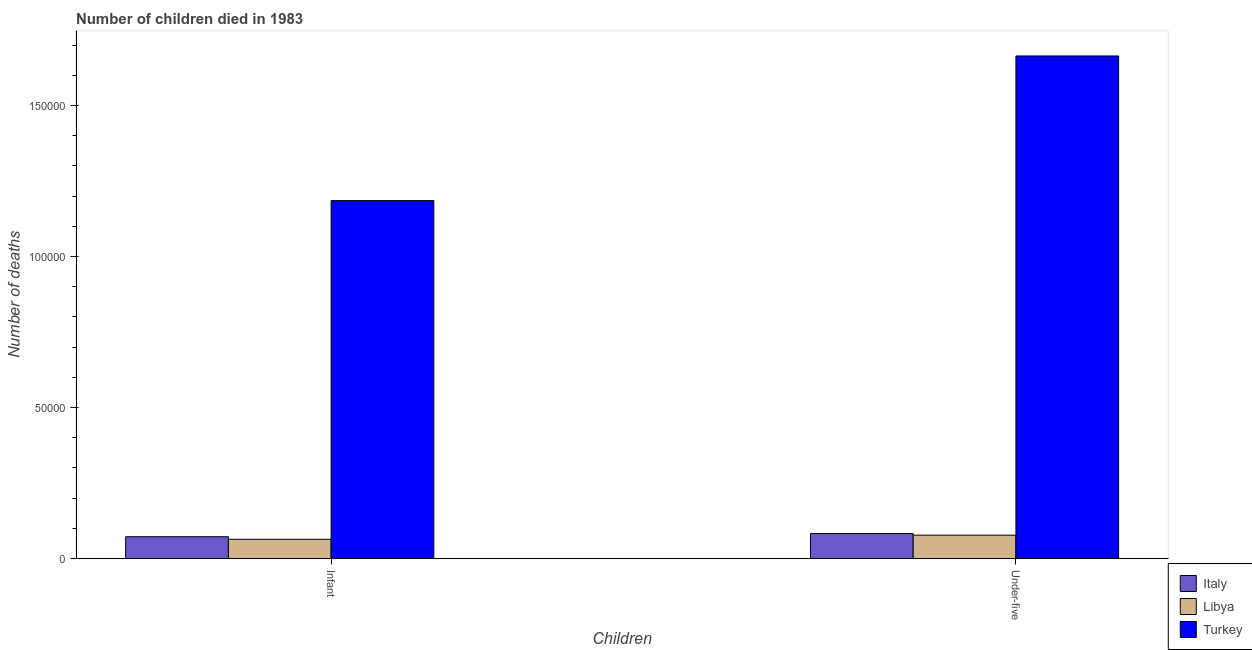Are the number of bars per tick equal to the number of legend labels?
Provide a succinct answer. Yes. Are the number of bars on each tick of the X-axis equal?
Offer a very short reply. Yes. How many bars are there on the 1st tick from the left?
Give a very brief answer. 3. What is the label of the 1st group of bars from the left?
Your answer should be compact. Infant. What is the number of infant deaths in Libya?
Your answer should be very brief. 6390. Across all countries, what is the maximum number of infant deaths?
Your answer should be very brief. 1.19e+05. Across all countries, what is the minimum number of under-five deaths?
Offer a very short reply. 7751. In which country was the number of under-five deaths minimum?
Provide a succinct answer. Libya. What is the total number of infant deaths in the graph?
Your answer should be very brief. 1.32e+05. What is the difference between the number of under-five deaths in Italy and that in Turkey?
Provide a succinct answer. -1.58e+05. What is the difference between the number of infant deaths in Libya and the number of under-five deaths in Italy?
Make the answer very short. -1890. What is the average number of under-five deaths per country?
Offer a terse response. 6.08e+04. What is the difference between the number of infant deaths and number of under-five deaths in Turkey?
Ensure brevity in your answer.  -4.79e+04. In how many countries, is the number of infant deaths greater than 110000 ?
Your answer should be very brief. 1. What is the ratio of the number of under-five deaths in Libya to that in Turkey?
Make the answer very short. 0.05. Is the number of infant deaths in Libya less than that in Turkey?
Offer a terse response. Yes. Are all the bars in the graph horizontal?
Give a very brief answer. No. Does the graph contain grids?
Offer a terse response. No. What is the title of the graph?
Your response must be concise. Number of children died in 1983. What is the label or title of the X-axis?
Offer a terse response. Children. What is the label or title of the Y-axis?
Ensure brevity in your answer.  Number of deaths. What is the Number of deaths of Italy in Infant?
Give a very brief answer. 7233. What is the Number of deaths of Libya in Infant?
Your answer should be compact. 6390. What is the Number of deaths in Turkey in Infant?
Make the answer very short. 1.19e+05. What is the Number of deaths of Italy in Under-five?
Your response must be concise. 8280. What is the Number of deaths in Libya in Under-five?
Provide a short and direct response. 7751. What is the Number of deaths in Turkey in Under-five?
Keep it short and to the point. 1.66e+05. Across all Children, what is the maximum Number of deaths of Italy?
Your response must be concise. 8280. Across all Children, what is the maximum Number of deaths in Libya?
Offer a terse response. 7751. Across all Children, what is the maximum Number of deaths in Turkey?
Ensure brevity in your answer.  1.66e+05. Across all Children, what is the minimum Number of deaths in Italy?
Give a very brief answer. 7233. Across all Children, what is the minimum Number of deaths of Libya?
Offer a very short reply. 6390. Across all Children, what is the minimum Number of deaths in Turkey?
Keep it short and to the point. 1.19e+05. What is the total Number of deaths in Italy in the graph?
Offer a terse response. 1.55e+04. What is the total Number of deaths in Libya in the graph?
Ensure brevity in your answer.  1.41e+04. What is the total Number of deaths in Turkey in the graph?
Provide a succinct answer. 2.85e+05. What is the difference between the Number of deaths in Italy in Infant and that in Under-five?
Provide a short and direct response. -1047. What is the difference between the Number of deaths of Libya in Infant and that in Under-five?
Provide a short and direct response. -1361. What is the difference between the Number of deaths of Turkey in Infant and that in Under-five?
Give a very brief answer. -4.79e+04. What is the difference between the Number of deaths of Italy in Infant and the Number of deaths of Libya in Under-five?
Your response must be concise. -518. What is the difference between the Number of deaths in Italy in Infant and the Number of deaths in Turkey in Under-five?
Your answer should be very brief. -1.59e+05. What is the difference between the Number of deaths of Libya in Infant and the Number of deaths of Turkey in Under-five?
Make the answer very short. -1.60e+05. What is the average Number of deaths of Italy per Children?
Your answer should be compact. 7756.5. What is the average Number of deaths in Libya per Children?
Your answer should be compact. 7070.5. What is the average Number of deaths of Turkey per Children?
Give a very brief answer. 1.42e+05. What is the difference between the Number of deaths of Italy and Number of deaths of Libya in Infant?
Provide a short and direct response. 843. What is the difference between the Number of deaths in Italy and Number of deaths in Turkey in Infant?
Your response must be concise. -1.11e+05. What is the difference between the Number of deaths in Libya and Number of deaths in Turkey in Infant?
Ensure brevity in your answer.  -1.12e+05. What is the difference between the Number of deaths in Italy and Number of deaths in Libya in Under-five?
Your answer should be very brief. 529. What is the difference between the Number of deaths in Italy and Number of deaths in Turkey in Under-five?
Keep it short and to the point. -1.58e+05. What is the difference between the Number of deaths in Libya and Number of deaths in Turkey in Under-five?
Your answer should be compact. -1.59e+05. What is the ratio of the Number of deaths in Italy in Infant to that in Under-five?
Provide a short and direct response. 0.87. What is the ratio of the Number of deaths in Libya in Infant to that in Under-five?
Ensure brevity in your answer.  0.82. What is the ratio of the Number of deaths of Turkey in Infant to that in Under-five?
Your response must be concise. 0.71. What is the difference between the highest and the second highest Number of deaths in Italy?
Your response must be concise. 1047. What is the difference between the highest and the second highest Number of deaths of Libya?
Make the answer very short. 1361. What is the difference between the highest and the second highest Number of deaths of Turkey?
Your answer should be compact. 4.79e+04. What is the difference between the highest and the lowest Number of deaths in Italy?
Your answer should be very brief. 1047. What is the difference between the highest and the lowest Number of deaths in Libya?
Provide a short and direct response. 1361. What is the difference between the highest and the lowest Number of deaths in Turkey?
Make the answer very short. 4.79e+04. 